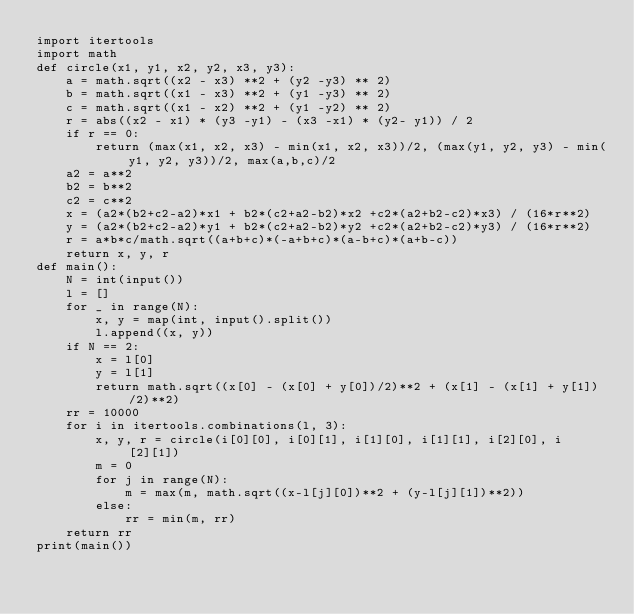Convert code to text. <code><loc_0><loc_0><loc_500><loc_500><_Python_>import itertools
import math
def circle(x1, y1, x2, y2, x3, y3):
    a = math.sqrt((x2 - x3) **2 + (y2 -y3) ** 2)
    b = math.sqrt((x1 - x3) **2 + (y1 -y3) ** 2)
    c = math.sqrt((x1 - x2) **2 + (y1 -y2) ** 2)
    r = abs((x2 - x1) * (y3 -y1) - (x3 -x1) * (y2- y1)) / 2
    if r == 0:
        return (max(x1, x2, x3) - min(x1, x2, x3))/2, (max(y1, y2, y3) - min(y1, y2, y3))/2, max(a,b,c)/2
    a2 = a**2
    b2 = b**2
    c2 = c**2
    x = (a2*(b2+c2-a2)*x1 + b2*(c2+a2-b2)*x2 +c2*(a2+b2-c2)*x3) / (16*r**2)
    y = (a2*(b2+c2-a2)*y1 + b2*(c2+a2-b2)*y2 +c2*(a2+b2-c2)*y3) / (16*r**2)
    r = a*b*c/math.sqrt((a+b+c)*(-a+b+c)*(a-b+c)*(a+b-c))
    return x, y, r
def main():
    N = int(input())
    l = []
    for _ in range(N):
        x, y = map(int, input().split())
        l.append((x, y))
    if N == 2:
        x = l[0]
        y = l[1]
        return math.sqrt((x[0] - (x[0] + y[0])/2)**2 + (x[1] - (x[1] + y[1])/2)**2)
    rr = 10000
    for i in itertools.combinations(l, 3):
        x, y, r = circle(i[0][0], i[0][1], i[1][0], i[1][1], i[2][0], i[2][1])
        m = 0
        for j in range(N):
            m = max(m, math.sqrt((x-l[j][0])**2 + (y-l[j][1])**2))
        else:
            rr = min(m, rr)
    return rr
print(main())
</code> 